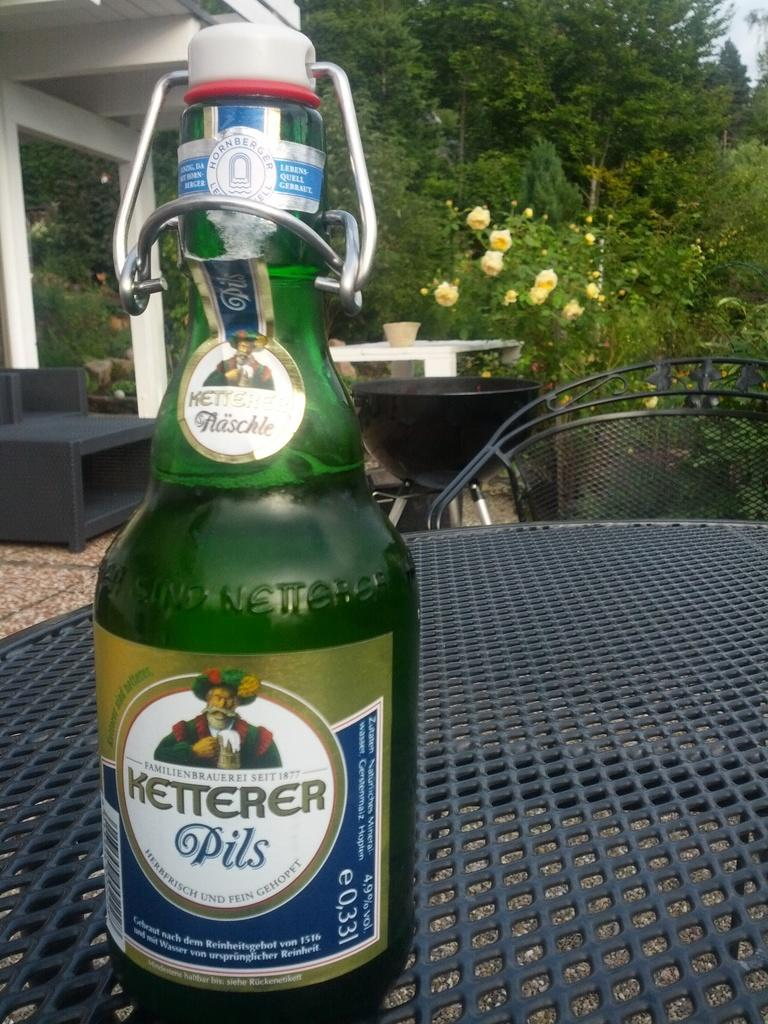<image>
Provide a brief description of the given image. a closed bottle of ketterer pils on the table  sitting outside 